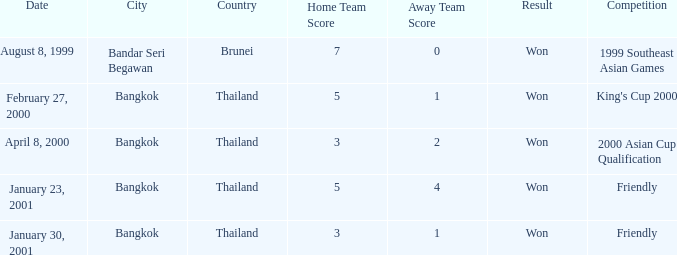In which contest was a match held with a score of 3-1? Friendly. 